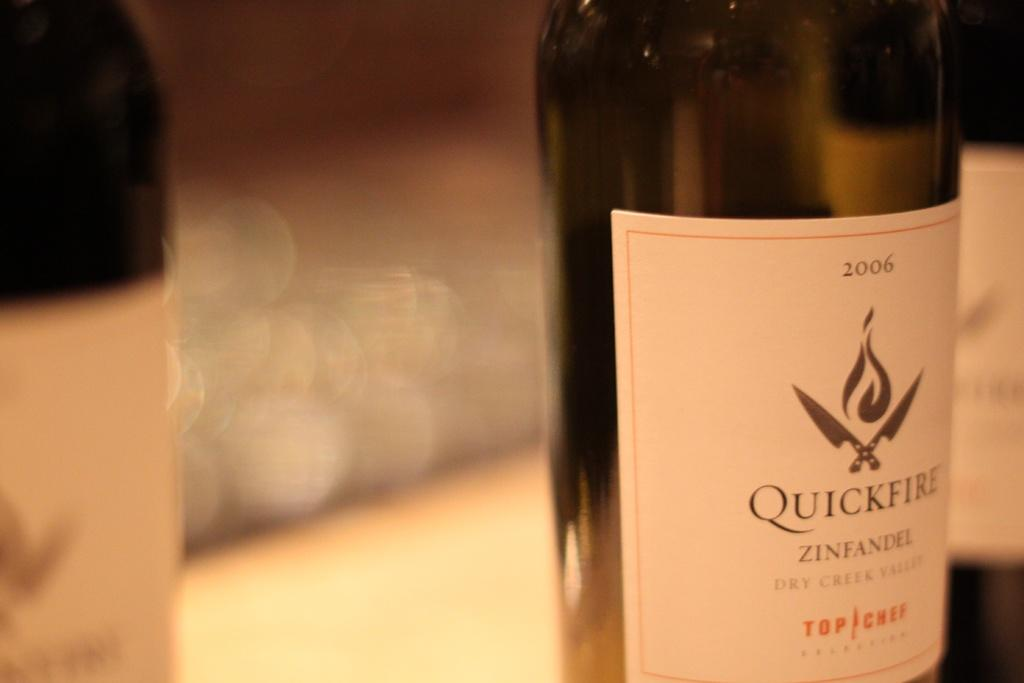What is the main object in the center of the image? There is a bottle in the center of the image. What can be seen on the bottle? There is text written on the bottle. Can you describe the background of the image? The background of the image is blurry. What type of argument is taking place in the image? There is no argument present in the image; it features a bottle with text on it and a blurry background. How does the pollution affect the bottle in the image? There is no pollution present in the image; it features a bottle with text on it and a blurry background. 